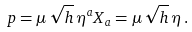Convert formula to latex. <formula><loc_0><loc_0><loc_500><loc_500>p = \mu \, \sqrt { h } \, \eta ^ { a } X _ { a } = \mu \, \sqrt { h } \, { \eta } \, .</formula> 